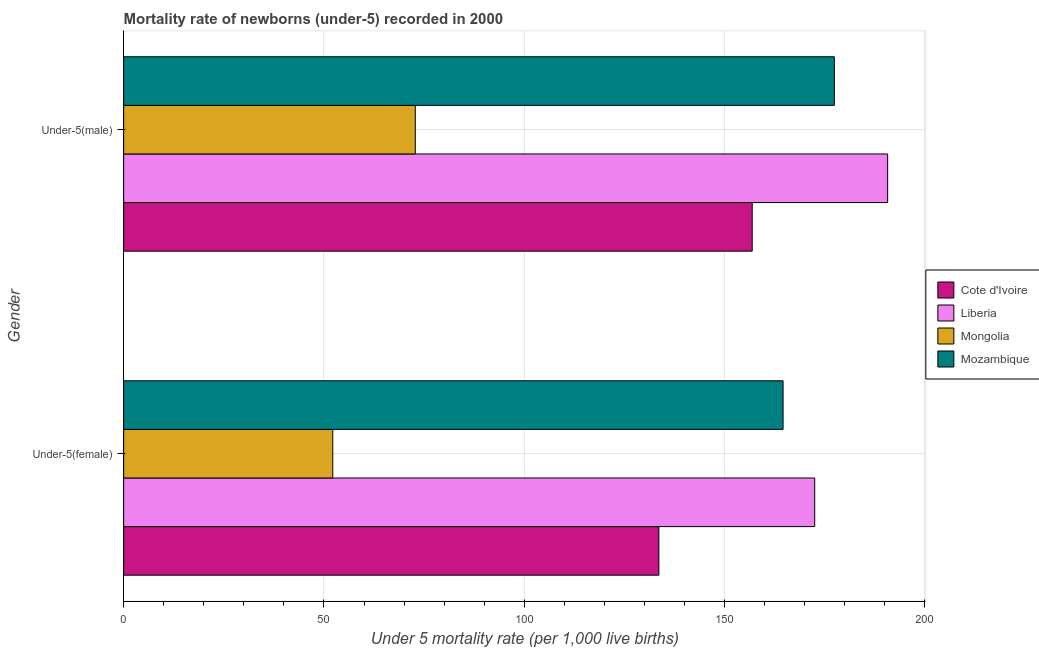Are the number of bars per tick equal to the number of legend labels?
Offer a terse response. Yes. Are the number of bars on each tick of the Y-axis equal?
Offer a terse response. Yes. How many bars are there on the 2nd tick from the top?
Your answer should be very brief. 4. How many bars are there on the 2nd tick from the bottom?
Provide a succinct answer. 4. What is the label of the 2nd group of bars from the top?
Your answer should be very brief. Under-5(female). What is the under-5 female mortality rate in Liberia?
Keep it short and to the point. 172.5. Across all countries, what is the maximum under-5 male mortality rate?
Make the answer very short. 190.7. Across all countries, what is the minimum under-5 male mortality rate?
Keep it short and to the point. 72.8. In which country was the under-5 male mortality rate maximum?
Provide a short and direct response. Liberia. In which country was the under-5 male mortality rate minimum?
Ensure brevity in your answer.  Mongolia. What is the total under-5 female mortality rate in the graph?
Offer a terse response. 522.9. What is the difference between the under-5 male mortality rate in Mozambique and that in Mongolia?
Your response must be concise. 104.6. What is the difference between the under-5 male mortality rate in Mongolia and the under-5 female mortality rate in Liberia?
Keep it short and to the point. -99.7. What is the average under-5 female mortality rate per country?
Keep it short and to the point. 130.72. What is the difference between the under-5 male mortality rate and under-5 female mortality rate in Cote d'Ivoire?
Your answer should be very brief. 23.3. What is the ratio of the under-5 male mortality rate in Liberia to that in Cote d'Ivoire?
Offer a terse response. 1.22. In how many countries, is the under-5 female mortality rate greater than the average under-5 female mortality rate taken over all countries?
Provide a succinct answer. 3. What does the 4th bar from the top in Under-5(male) represents?
Offer a very short reply. Cote d'Ivoire. What does the 2nd bar from the bottom in Under-5(female) represents?
Provide a succinct answer. Liberia. How many countries are there in the graph?
Provide a succinct answer. 4. Are the values on the major ticks of X-axis written in scientific E-notation?
Offer a terse response. No. Does the graph contain any zero values?
Provide a succinct answer. No. How are the legend labels stacked?
Provide a succinct answer. Vertical. What is the title of the graph?
Offer a very short reply. Mortality rate of newborns (under-5) recorded in 2000. What is the label or title of the X-axis?
Your answer should be compact. Under 5 mortality rate (per 1,0 live births). What is the Under 5 mortality rate (per 1,000 live births) in Cote d'Ivoire in Under-5(female)?
Your answer should be very brief. 133.6. What is the Under 5 mortality rate (per 1,000 live births) in Liberia in Under-5(female)?
Your response must be concise. 172.5. What is the Under 5 mortality rate (per 1,000 live births) in Mongolia in Under-5(female)?
Offer a terse response. 52.2. What is the Under 5 mortality rate (per 1,000 live births) of Mozambique in Under-5(female)?
Make the answer very short. 164.6. What is the Under 5 mortality rate (per 1,000 live births) in Cote d'Ivoire in Under-5(male)?
Your answer should be compact. 156.9. What is the Under 5 mortality rate (per 1,000 live births) of Liberia in Under-5(male)?
Ensure brevity in your answer.  190.7. What is the Under 5 mortality rate (per 1,000 live births) of Mongolia in Under-5(male)?
Make the answer very short. 72.8. What is the Under 5 mortality rate (per 1,000 live births) in Mozambique in Under-5(male)?
Your response must be concise. 177.4. Across all Gender, what is the maximum Under 5 mortality rate (per 1,000 live births) in Cote d'Ivoire?
Give a very brief answer. 156.9. Across all Gender, what is the maximum Under 5 mortality rate (per 1,000 live births) in Liberia?
Offer a very short reply. 190.7. Across all Gender, what is the maximum Under 5 mortality rate (per 1,000 live births) of Mongolia?
Your answer should be compact. 72.8. Across all Gender, what is the maximum Under 5 mortality rate (per 1,000 live births) of Mozambique?
Your answer should be compact. 177.4. Across all Gender, what is the minimum Under 5 mortality rate (per 1,000 live births) of Cote d'Ivoire?
Keep it short and to the point. 133.6. Across all Gender, what is the minimum Under 5 mortality rate (per 1,000 live births) in Liberia?
Offer a very short reply. 172.5. Across all Gender, what is the minimum Under 5 mortality rate (per 1,000 live births) of Mongolia?
Your answer should be compact. 52.2. Across all Gender, what is the minimum Under 5 mortality rate (per 1,000 live births) of Mozambique?
Give a very brief answer. 164.6. What is the total Under 5 mortality rate (per 1,000 live births) in Cote d'Ivoire in the graph?
Provide a succinct answer. 290.5. What is the total Under 5 mortality rate (per 1,000 live births) of Liberia in the graph?
Provide a succinct answer. 363.2. What is the total Under 5 mortality rate (per 1,000 live births) in Mongolia in the graph?
Offer a very short reply. 125. What is the total Under 5 mortality rate (per 1,000 live births) in Mozambique in the graph?
Offer a very short reply. 342. What is the difference between the Under 5 mortality rate (per 1,000 live births) of Cote d'Ivoire in Under-5(female) and that in Under-5(male)?
Provide a succinct answer. -23.3. What is the difference between the Under 5 mortality rate (per 1,000 live births) in Liberia in Under-5(female) and that in Under-5(male)?
Ensure brevity in your answer.  -18.2. What is the difference between the Under 5 mortality rate (per 1,000 live births) in Mongolia in Under-5(female) and that in Under-5(male)?
Your answer should be very brief. -20.6. What is the difference between the Under 5 mortality rate (per 1,000 live births) of Mozambique in Under-5(female) and that in Under-5(male)?
Ensure brevity in your answer.  -12.8. What is the difference between the Under 5 mortality rate (per 1,000 live births) in Cote d'Ivoire in Under-5(female) and the Under 5 mortality rate (per 1,000 live births) in Liberia in Under-5(male)?
Your response must be concise. -57.1. What is the difference between the Under 5 mortality rate (per 1,000 live births) in Cote d'Ivoire in Under-5(female) and the Under 5 mortality rate (per 1,000 live births) in Mongolia in Under-5(male)?
Ensure brevity in your answer.  60.8. What is the difference between the Under 5 mortality rate (per 1,000 live births) of Cote d'Ivoire in Under-5(female) and the Under 5 mortality rate (per 1,000 live births) of Mozambique in Under-5(male)?
Make the answer very short. -43.8. What is the difference between the Under 5 mortality rate (per 1,000 live births) in Liberia in Under-5(female) and the Under 5 mortality rate (per 1,000 live births) in Mongolia in Under-5(male)?
Your answer should be compact. 99.7. What is the difference between the Under 5 mortality rate (per 1,000 live births) in Mongolia in Under-5(female) and the Under 5 mortality rate (per 1,000 live births) in Mozambique in Under-5(male)?
Provide a succinct answer. -125.2. What is the average Under 5 mortality rate (per 1,000 live births) in Cote d'Ivoire per Gender?
Offer a terse response. 145.25. What is the average Under 5 mortality rate (per 1,000 live births) of Liberia per Gender?
Offer a terse response. 181.6. What is the average Under 5 mortality rate (per 1,000 live births) in Mongolia per Gender?
Make the answer very short. 62.5. What is the average Under 5 mortality rate (per 1,000 live births) in Mozambique per Gender?
Offer a terse response. 171. What is the difference between the Under 5 mortality rate (per 1,000 live births) in Cote d'Ivoire and Under 5 mortality rate (per 1,000 live births) in Liberia in Under-5(female)?
Keep it short and to the point. -38.9. What is the difference between the Under 5 mortality rate (per 1,000 live births) in Cote d'Ivoire and Under 5 mortality rate (per 1,000 live births) in Mongolia in Under-5(female)?
Provide a succinct answer. 81.4. What is the difference between the Under 5 mortality rate (per 1,000 live births) of Cote d'Ivoire and Under 5 mortality rate (per 1,000 live births) of Mozambique in Under-5(female)?
Offer a very short reply. -31. What is the difference between the Under 5 mortality rate (per 1,000 live births) of Liberia and Under 5 mortality rate (per 1,000 live births) of Mongolia in Under-5(female)?
Offer a terse response. 120.3. What is the difference between the Under 5 mortality rate (per 1,000 live births) in Liberia and Under 5 mortality rate (per 1,000 live births) in Mozambique in Under-5(female)?
Your response must be concise. 7.9. What is the difference between the Under 5 mortality rate (per 1,000 live births) in Mongolia and Under 5 mortality rate (per 1,000 live births) in Mozambique in Under-5(female)?
Your answer should be very brief. -112.4. What is the difference between the Under 5 mortality rate (per 1,000 live births) of Cote d'Ivoire and Under 5 mortality rate (per 1,000 live births) of Liberia in Under-5(male)?
Your answer should be very brief. -33.8. What is the difference between the Under 5 mortality rate (per 1,000 live births) in Cote d'Ivoire and Under 5 mortality rate (per 1,000 live births) in Mongolia in Under-5(male)?
Ensure brevity in your answer.  84.1. What is the difference between the Under 5 mortality rate (per 1,000 live births) in Cote d'Ivoire and Under 5 mortality rate (per 1,000 live births) in Mozambique in Under-5(male)?
Your response must be concise. -20.5. What is the difference between the Under 5 mortality rate (per 1,000 live births) of Liberia and Under 5 mortality rate (per 1,000 live births) of Mongolia in Under-5(male)?
Offer a terse response. 117.9. What is the difference between the Under 5 mortality rate (per 1,000 live births) in Mongolia and Under 5 mortality rate (per 1,000 live births) in Mozambique in Under-5(male)?
Ensure brevity in your answer.  -104.6. What is the ratio of the Under 5 mortality rate (per 1,000 live births) of Cote d'Ivoire in Under-5(female) to that in Under-5(male)?
Provide a short and direct response. 0.85. What is the ratio of the Under 5 mortality rate (per 1,000 live births) of Liberia in Under-5(female) to that in Under-5(male)?
Provide a short and direct response. 0.9. What is the ratio of the Under 5 mortality rate (per 1,000 live births) in Mongolia in Under-5(female) to that in Under-5(male)?
Offer a terse response. 0.72. What is the ratio of the Under 5 mortality rate (per 1,000 live births) in Mozambique in Under-5(female) to that in Under-5(male)?
Offer a terse response. 0.93. What is the difference between the highest and the second highest Under 5 mortality rate (per 1,000 live births) in Cote d'Ivoire?
Your answer should be compact. 23.3. What is the difference between the highest and the second highest Under 5 mortality rate (per 1,000 live births) in Mongolia?
Provide a succinct answer. 20.6. What is the difference between the highest and the lowest Under 5 mortality rate (per 1,000 live births) of Cote d'Ivoire?
Give a very brief answer. 23.3. What is the difference between the highest and the lowest Under 5 mortality rate (per 1,000 live births) of Mongolia?
Ensure brevity in your answer.  20.6. 